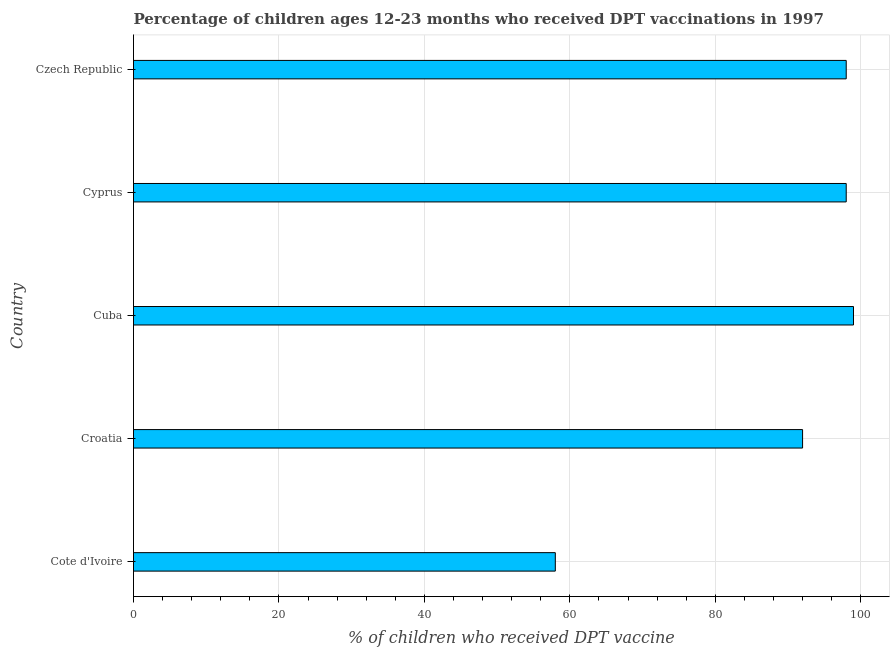What is the title of the graph?
Make the answer very short. Percentage of children ages 12-23 months who received DPT vaccinations in 1997. What is the label or title of the X-axis?
Your answer should be very brief. % of children who received DPT vaccine. What is the label or title of the Y-axis?
Your response must be concise. Country. What is the percentage of children who received dpt vaccine in Croatia?
Give a very brief answer. 92. Across all countries, what is the maximum percentage of children who received dpt vaccine?
Your answer should be compact. 99. In which country was the percentage of children who received dpt vaccine maximum?
Make the answer very short. Cuba. In which country was the percentage of children who received dpt vaccine minimum?
Your answer should be compact. Cote d'Ivoire. What is the sum of the percentage of children who received dpt vaccine?
Make the answer very short. 445. What is the difference between the percentage of children who received dpt vaccine in Croatia and Cyprus?
Keep it short and to the point. -6. What is the average percentage of children who received dpt vaccine per country?
Offer a terse response. 89. What is the ratio of the percentage of children who received dpt vaccine in Cote d'Ivoire to that in Cyprus?
Your answer should be compact. 0.59. Is the percentage of children who received dpt vaccine in Croatia less than that in Czech Republic?
Provide a short and direct response. Yes. Is the difference between the percentage of children who received dpt vaccine in Cote d'Ivoire and Czech Republic greater than the difference between any two countries?
Your response must be concise. No. What is the difference between the highest and the second highest percentage of children who received dpt vaccine?
Your response must be concise. 1. What is the difference between the highest and the lowest percentage of children who received dpt vaccine?
Provide a succinct answer. 41. In how many countries, is the percentage of children who received dpt vaccine greater than the average percentage of children who received dpt vaccine taken over all countries?
Provide a succinct answer. 4. How many countries are there in the graph?
Keep it short and to the point. 5. Are the values on the major ticks of X-axis written in scientific E-notation?
Your answer should be very brief. No. What is the % of children who received DPT vaccine in Cote d'Ivoire?
Offer a very short reply. 58. What is the % of children who received DPT vaccine in Croatia?
Make the answer very short. 92. What is the % of children who received DPT vaccine in Cyprus?
Offer a terse response. 98. What is the % of children who received DPT vaccine in Czech Republic?
Ensure brevity in your answer.  98. What is the difference between the % of children who received DPT vaccine in Cote d'Ivoire and Croatia?
Offer a very short reply. -34. What is the difference between the % of children who received DPT vaccine in Cote d'Ivoire and Cuba?
Your answer should be very brief. -41. What is the difference between the % of children who received DPT vaccine in Cote d'Ivoire and Cyprus?
Make the answer very short. -40. What is the difference between the % of children who received DPT vaccine in Cote d'Ivoire and Czech Republic?
Ensure brevity in your answer.  -40. What is the difference between the % of children who received DPT vaccine in Croatia and Cyprus?
Your response must be concise. -6. What is the difference between the % of children who received DPT vaccine in Croatia and Czech Republic?
Offer a terse response. -6. What is the difference between the % of children who received DPT vaccine in Cuba and Cyprus?
Offer a terse response. 1. What is the ratio of the % of children who received DPT vaccine in Cote d'Ivoire to that in Croatia?
Your answer should be compact. 0.63. What is the ratio of the % of children who received DPT vaccine in Cote d'Ivoire to that in Cuba?
Offer a terse response. 0.59. What is the ratio of the % of children who received DPT vaccine in Cote d'Ivoire to that in Cyprus?
Offer a terse response. 0.59. What is the ratio of the % of children who received DPT vaccine in Cote d'Ivoire to that in Czech Republic?
Give a very brief answer. 0.59. What is the ratio of the % of children who received DPT vaccine in Croatia to that in Cuba?
Keep it short and to the point. 0.93. What is the ratio of the % of children who received DPT vaccine in Croatia to that in Cyprus?
Make the answer very short. 0.94. What is the ratio of the % of children who received DPT vaccine in Croatia to that in Czech Republic?
Make the answer very short. 0.94. What is the ratio of the % of children who received DPT vaccine in Cuba to that in Cyprus?
Provide a succinct answer. 1.01. What is the ratio of the % of children who received DPT vaccine in Cuba to that in Czech Republic?
Provide a succinct answer. 1.01. What is the ratio of the % of children who received DPT vaccine in Cyprus to that in Czech Republic?
Make the answer very short. 1. 